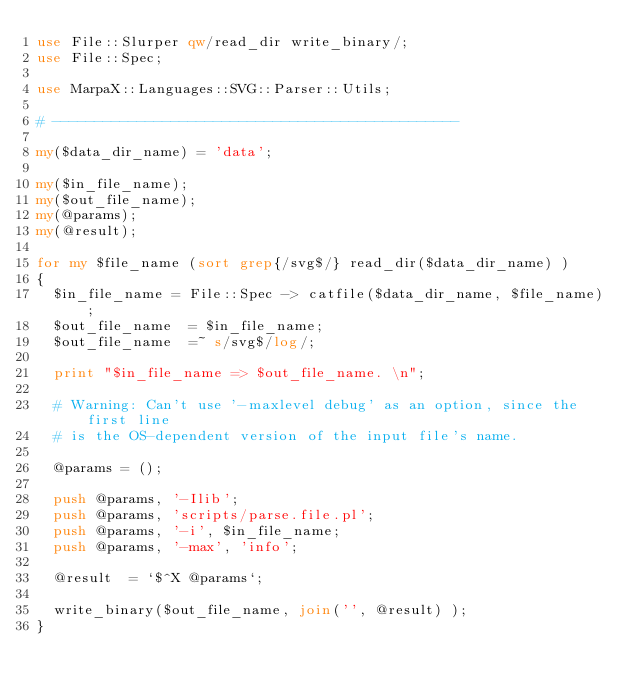<code> <loc_0><loc_0><loc_500><loc_500><_Perl_>use File::Slurper qw/read_dir write_binary/;
use File::Spec;

use MarpaX::Languages::SVG::Parser::Utils;

# ------------------------------------------------

my($data_dir_name) = 'data';

my($in_file_name);
my($out_file_name);
my(@params);
my(@result);

for my $file_name (sort grep{/svg$/} read_dir($data_dir_name) )
{
	$in_file_name	= File::Spec -> catfile($data_dir_name, $file_name);
	$out_file_name	= $in_file_name;
	$out_file_name	=~ s/svg$/log/;

	print "$in_file_name => $out_file_name. \n";

	# Warning: Can't use '-maxlevel debug' as an option, since the first line
	# is the OS-dependent version of the input file's name.

	@params = ();

	push @params, '-Ilib';
	push @params, 'scripts/parse.file.pl';
	push @params, '-i', $in_file_name;
	push @params, '-max', 'info';

	@result  = `$^X @params`;

	write_binary($out_file_name, join('', @result) );
}
</code> 